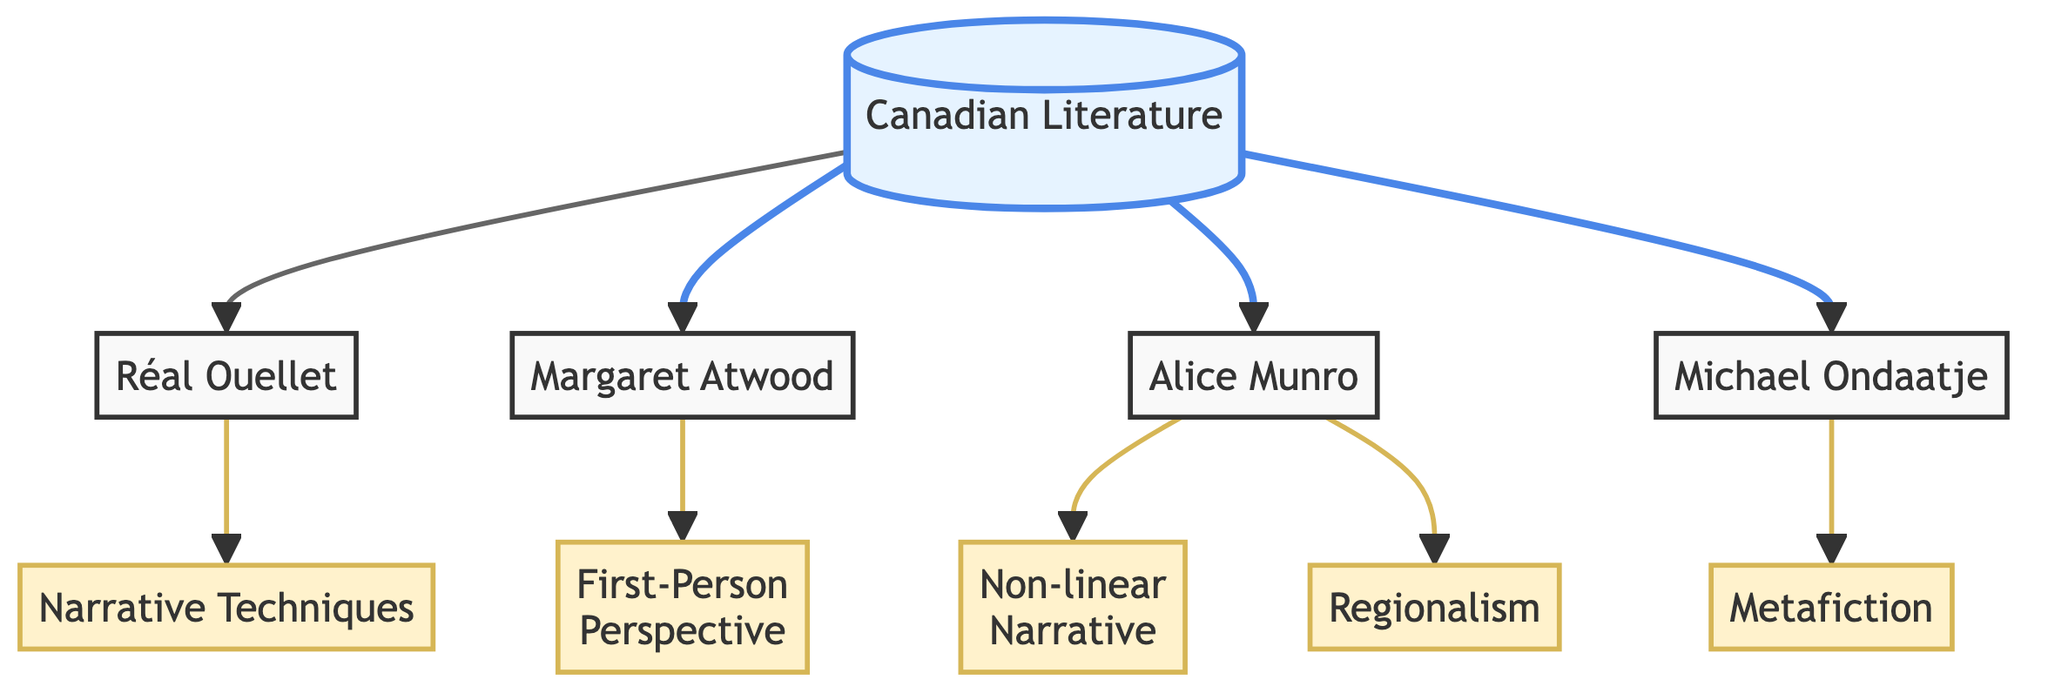What is the total number of nodes in the diagram? The nodes in the diagram are Canadian Literature, Réal Ouellet, Margaret Atwood, Alice Munro, Michael Ondaatje, Narrative Techniques, First-Person Perspective, Non-linear Narrative, Metafiction, and Regionalism. Counting these, there are a total of 10 nodes.
Answer: 10 Which narrative technique is associated with Margaret Atwood? In the diagram, there is a directed edge from Margaret Atwood to First-Person Perspective indicating that this narrative technique is associated with her work.
Answer: First-Person Perspective How many edges originate from the node "Canadian Literature"? The diagram shows that "Canadian Literature" has directed edges leading to Réal Ouellet, Margaret Atwood, Alice Munro, and Michael Ondaatje. Counting these edges, there are 4 edges that originate from "Canadian Literature".
Answer: 4 What narrative technique is linked to Alice Munro? The directed edge from Alice Munro leads to Non-linear Narrative in the diagram, indicating that this technique is linked to her writing style.
Answer: Non-linear Narrative Which writer is connected to both Metafiction and Regionalism? The node for Michael Ondaatje is connected to Metafiction, while Alice Munro is connected to Regionalism. Therefore, there isn't a single writer connected to both; these are separate connections.
Answer: None What type of question is asked about the connections with Réal Ouellet? The diagram shows that Réal Ouellet connects to Narrative Techniques, thereby indicating that the question could involve exploring which narrative techniques are linked to him.
Answer: Narrative Techniques Which author has connections to two different narrative techniques? Alice Munro has connections to Non-linear Narrative and Regionalism, making her the author with connections to two different techniques in the diagram.
Answer: Alice Munro What is the relationship between Michael Ondaatje and narrative techniques? The diagram shows that Michael Ondaatje has a directed edge to Metafiction, highlighting that he is directly related to this narrative technique.
Answer: Metafiction 